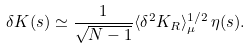Convert formula to latex. <formula><loc_0><loc_0><loc_500><loc_500>\delta K ( s ) \simeq \frac { 1 } { \sqrt { N - 1 } } \langle \delta ^ { 2 } K _ { R } \rangle ^ { 1 / 2 } _ { \mu } \, \eta ( s ) .</formula> 